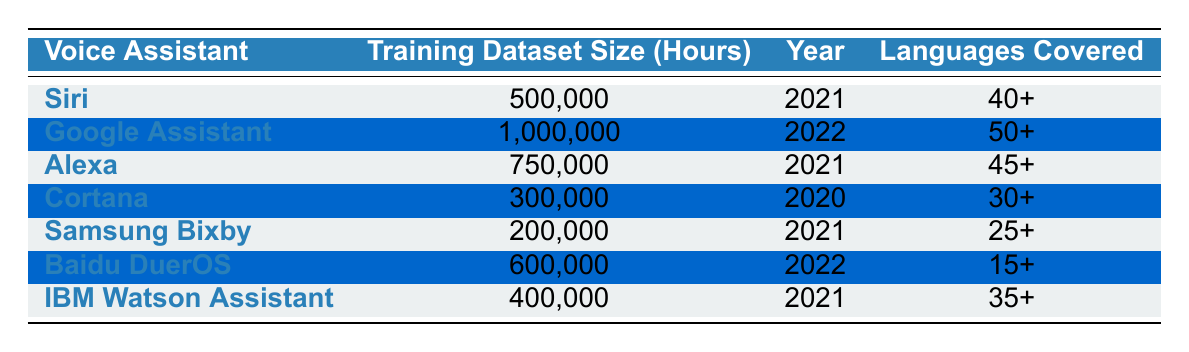What is the training dataset size of Google Assistant? The training dataset size for Google Assistant is listed directly in the table. I look at the corresponding row for Google Assistant and find it is 1,000,000 hours.
Answer: 1,000,000 Which voice assistant has the smallest training dataset size? To find the smallest dataset size, I compare all the values in the "Training Dataset Size (Hours)" column. The smallest value among them is for Samsung Bixby at 200,000 hours.
Answer: Samsung Bixby How many languages does Alexa support? The number of languages covered by Alexa is in its row under "Languages Covered." It states that Alexa supports 45+ languages.
Answer: 45+ What is the difference in training dataset size between Siri and IBM Watson Assistant? First, I note the training dataset sizes for both voice assistants from the table: Siri has 500,000 hours and IBM Watson Assistant has 400,000 hours. To find the difference, I subtract: 500,000 - 400,000 = 100,000 hours.
Answer: 100,000 Is the training dataset size for Baidu DuerOS greater than that of Cortana? To answer this, I compare the training dataset sizes of both voice assistants: Baidu DuerOS has 600,000 hours and Cortana has 300,000 hours. Since 600,000 is greater than 300,000, the answer is yes.
Answer: Yes What is the average training dataset size for the assistants trained in 2021? I need to find dataset sizes for all assistants listed in 2021, which are Siri (500,000), Alexa (750,000), Samsung Bixby (200,000), and IBM Watson Assistant (400,000). Adding these gives me a total of 1,850,000 hours. There are 4 entries, so to find the average, I divide the total by 4: 1,850,000 / 4 = 462,500.
Answer: 462,500 Which voice assistant covers the most languages, and how many does it support? I look at the "Languages Covered" column and compare the values. Google Assistant supports 50+ languages, which is the highest on the list.
Answer: Google Assistant, 50+ Is it true that all voice assistants listed were trained in 2022? I check the "Year" column for all voice assistants. Google Assistant and Baidu DuerOS are the only ones that were trained in 2022, while others were trained in 2021 or 2020. Hence, it's false that all were trained in 2022.
Answer: No How many languages do all voice assistants combined support? To answer this, I need to sum the number of languages listed for each voice assistant: Siri (40+), Google Assistant (50+), Alexa (45+), Cortana (30+), Samsung Bixby (25+), Baidu DuerOS (15+), and IBM Watson Assistant (35+), totaling 40 + 50 + 45 + 30 + 25 + 15 + 35 = 230+. However, since these are categorical and not explicitly summed numerical data, the total can’t be numerically summed, but one can assert 230+ languages covered overall.
Answer: 230+ 